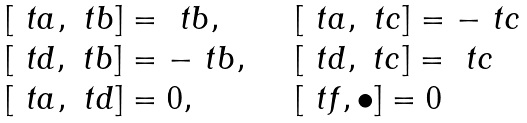<formula> <loc_0><loc_0><loc_500><loc_500>\begin{array} { l l l } & [ \ t a , \ t b ] = \ t b , \quad & [ \ t a , \ t c ] = - \ t c \\ & [ \ t d , \ t b ] = - \ t b , \quad & [ \ t d , \ t c ] = \ t c \\ & [ \ t a , \ t d ] = 0 , \quad & [ \ t f , \bullet ] = 0 \\ \end{array}</formula> 